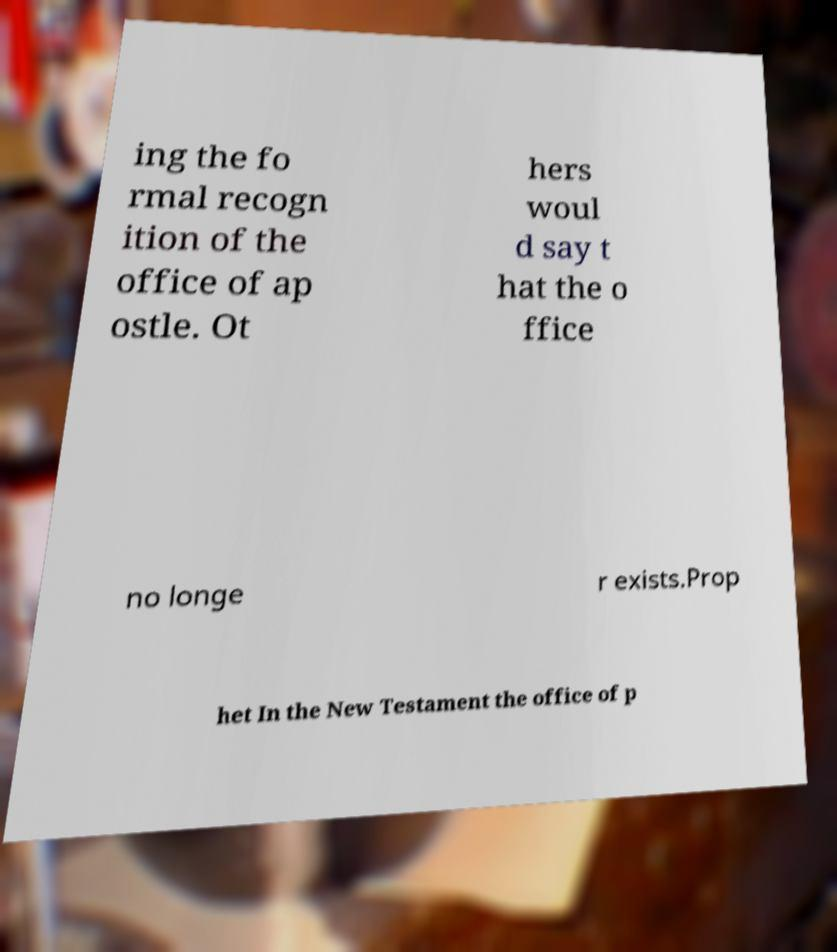Please read and relay the text visible in this image. What does it say? ing the fo rmal recogn ition of the office of ap ostle. Ot hers woul d say t hat the o ffice no longe r exists.Prop het In the New Testament the office of p 